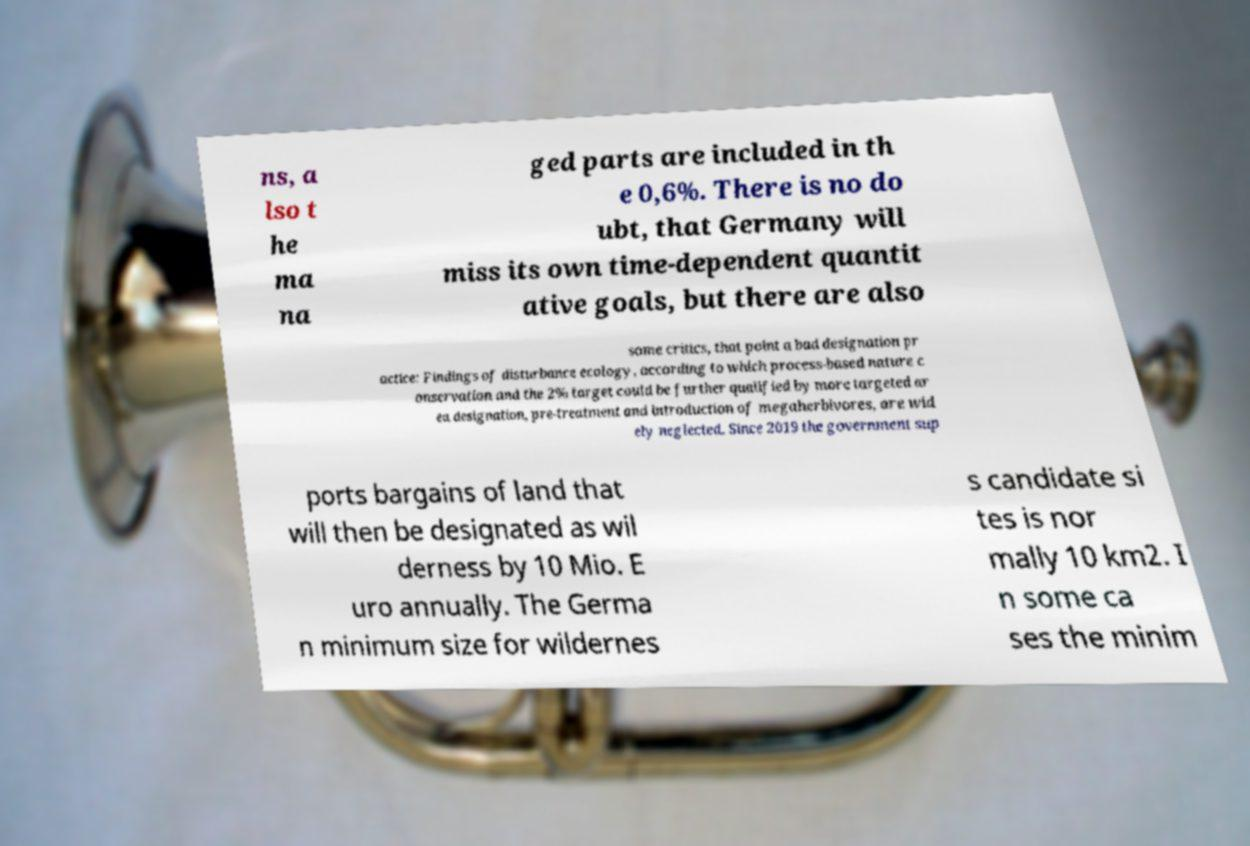For documentation purposes, I need the text within this image transcribed. Could you provide that? ns, a lso t he ma na ged parts are included in th e 0,6%. There is no do ubt, that Germany will miss its own time-dependent quantit ative goals, but there are also some critics, that point a bad designation pr actice: Findings of disturbance ecology, according to which process-based nature c onservation and the 2% target could be further qualified by more targeted ar ea designation, pre-treatment and introduction of megaherbivores, are wid ely neglected. Since 2019 the government sup ports bargains of land that will then be designated as wil derness by 10 Mio. E uro annually. The Germa n minimum size for wildernes s candidate si tes is nor mally 10 km2. I n some ca ses the minim 